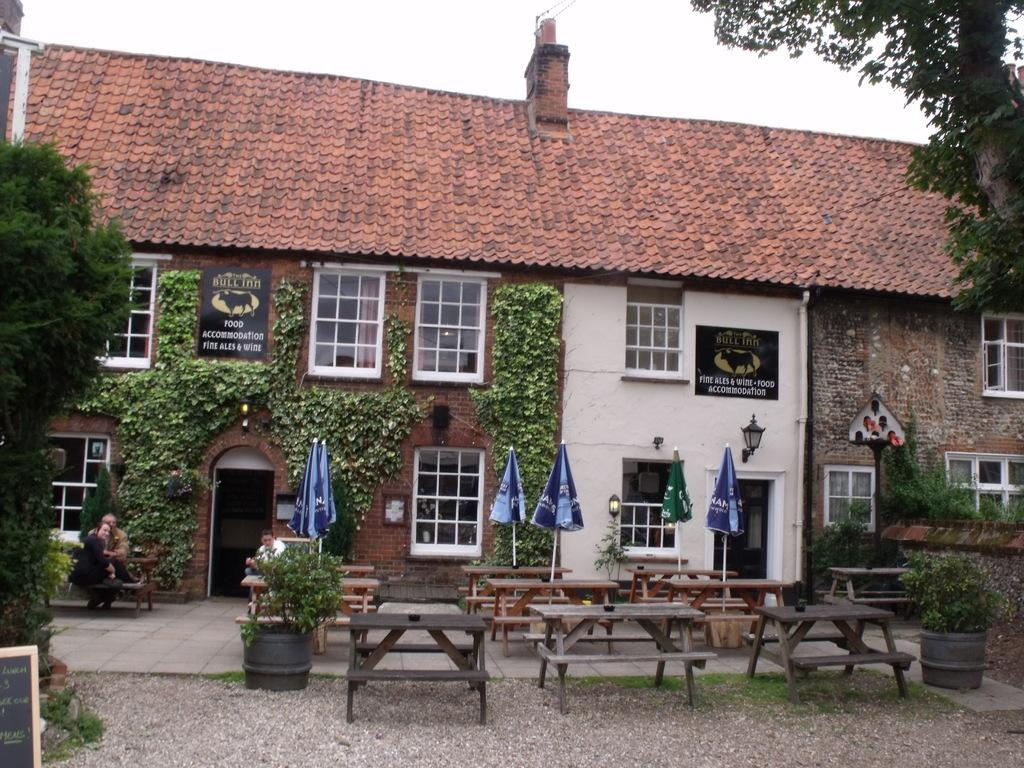What type of structures can be seen in the image? There are buildings in the image. What are the people in the image doing? There are persons sitting on benches in the image. What type of plants are present in the image? House plants are present in the image. What type of shade is provided in the image? Parasols are visible in the image. What type of lighting is present in the image? Street lights are in the image. What type of signage is present in the image? Name boards are present in the image. What type of vegetation is visible in the image? Trees are visible in the image. What type of infrastructure is present in the image? Cables are present in the image. What is visible in the background of the image? The sky is visible in the image. What type of tongue can be seen sticking out of the building in the image? There is no tongue present in the image, as it is a scene featuring buildings, benches, plants, parasols, street lights, name boards, trees, cables, and the sky. What type of beast is roaming around the persons sitting on benches in the image? There is no beast present in the image; it features people sitting on benches, buildings, plants, parasols, street lights, name boards, trees, cables, and the sky. 